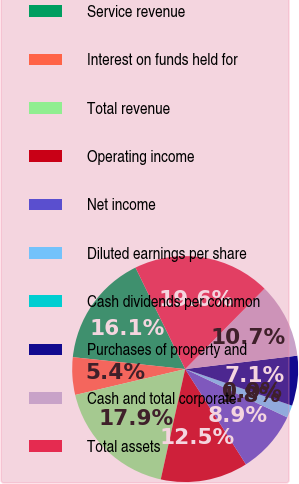Convert chart. <chart><loc_0><loc_0><loc_500><loc_500><pie_chart><fcel>Service revenue<fcel>Interest on funds held for<fcel>Total revenue<fcel>Operating income<fcel>Net income<fcel>Diluted earnings per share<fcel>Cash dividends per common<fcel>Purchases of property and<fcel>Cash and total corporate<fcel>Total assets<nl><fcel>16.07%<fcel>5.36%<fcel>17.85%<fcel>12.5%<fcel>8.93%<fcel>1.79%<fcel>0.0%<fcel>7.14%<fcel>10.71%<fcel>19.64%<nl></chart> 